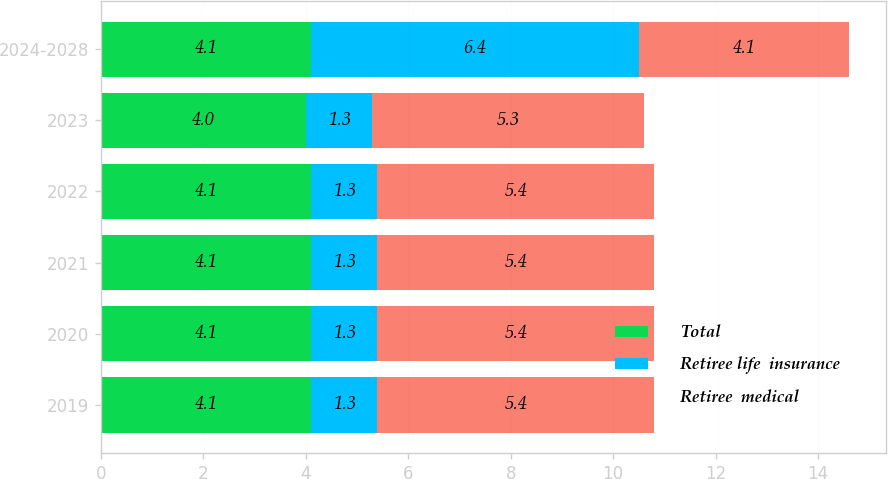Convert chart to OTSL. <chart><loc_0><loc_0><loc_500><loc_500><stacked_bar_chart><ecel><fcel>2019<fcel>2020<fcel>2021<fcel>2022<fcel>2023<fcel>2024-2028<nl><fcel>Total<fcel>4.1<fcel>4.1<fcel>4.1<fcel>4.1<fcel>4<fcel>4.1<nl><fcel>Retiree life  insurance<fcel>1.3<fcel>1.3<fcel>1.3<fcel>1.3<fcel>1.3<fcel>6.4<nl><fcel>Retiree  medical<fcel>5.4<fcel>5.4<fcel>5.4<fcel>5.4<fcel>5.3<fcel>4.1<nl></chart> 